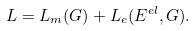Convert formula to latex. <formula><loc_0><loc_0><loc_500><loc_500>L = L _ { m } ( G ) + L _ { e } ( E ^ { e l } , G ) .</formula> 